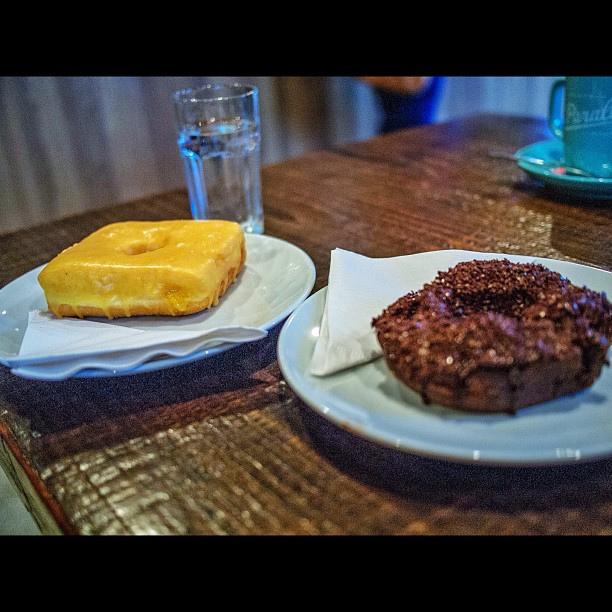What color is the frosting on the cake?
Keep it brief. Yellow. Are there grapes in the photo?
Keep it brief. No. What is in the glass?
Concise answer only. Water. How many glasses are on the table?
Answer briefly. 1. What surface does the plate sit atop?
Quick response, please. Table. What is the table made of?
Answer briefly. Wood. Is the glass of water sweating?
Be succinct. No. What type of glass is on the table?
Answer briefly. Water glass. Is there any liquid in the glass?
Answer briefly. Yes. Which one has the fewest marshmallows?
Answer briefly. Neither. What is the chef cooking?
Give a very brief answer. Donuts. How many doughnuts are there?
Quick response, please. 2. How many plates can you see?
Concise answer only. 2. Do the donuts have filling?
Quick response, please. No. What are the donuts sitting on?
Quick response, please. Plate. What shape is the plate?
Short answer required. Round. Does the glass have liquid in it?
Answer briefly. Yes. What meal of the day are they eating?
Answer briefly. Breakfast. What kind of meal is that?
Keep it brief. Breakfast. What color are the plates?
Short answer required. White. What type of beverage is in the glass closest to the donuts?
Quick response, please. Water. What is on the plates next to the food?
Keep it brief. Napkin. Is the glass empty?
Give a very brief answer. No. Is there hot chocolate on the table?
Keep it brief. No. Why would someone eat this?
Quick response, please. Hunger. 